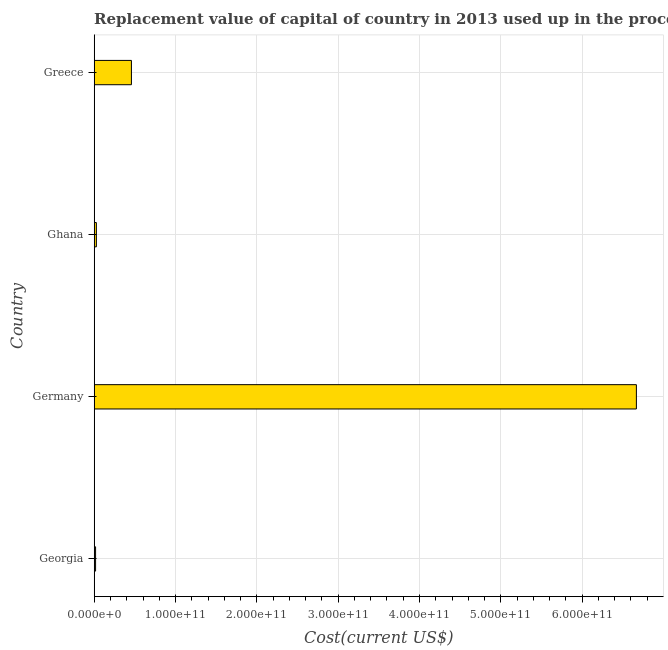Does the graph contain any zero values?
Make the answer very short. No. Does the graph contain grids?
Give a very brief answer. Yes. What is the title of the graph?
Provide a succinct answer. Replacement value of capital of country in 2013 used up in the process of production. What is the label or title of the X-axis?
Give a very brief answer. Cost(current US$). What is the consumption of fixed capital in Greece?
Offer a very short reply. 4.58e+1. Across all countries, what is the maximum consumption of fixed capital?
Provide a short and direct response. 6.67e+11. Across all countries, what is the minimum consumption of fixed capital?
Keep it short and to the point. 1.69e+09. In which country was the consumption of fixed capital minimum?
Keep it short and to the point. Georgia. What is the sum of the consumption of fixed capital?
Offer a terse response. 7.17e+11. What is the difference between the consumption of fixed capital in Germany and Ghana?
Your answer should be compact. 6.64e+11. What is the average consumption of fixed capital per country?
Offer a very short reply. 1.79e+11. What is the median consumption of fixed capital?
Offer a terse response. 2.42e+1. In how many countries, is the consumption of fixed capital greater than 540000000000 US$?
Your answer should be very brief. 1. What is the ratio of the consumption of fixed capital in Georgia to that in Greece?
Your answer should be very brief. 0.04. What is the difference between the highest and the second highest consumption of fixed capital?
Ensure brevity in your answer.  6.21e+11. What is the difference between the highest and the lowest consumption of fixed capital?
Provide a succinct answer. 6.65e+11. How many bars are there?
Provide a succinct answer. 4. Are all the bars in the graph horizontal?
Ensure brevity in your answer.  Yes. What is the difference between two consecutive major ticks on the X-axis?
Keep it short and to the point. 1.00e+11. Are the values on the major ticks of X-axis written in scientific E-notation?
Provide a succinct answer. Yes. What is the Cost(current US$) in Georgia?
Make the answer very short. 1.69e+09. What is the Cost(current US$) of Germany?
Ensure brevity in your answer.  6.67e+11. What is the Cost(current US$) of Ghana?
Your answer should be very brief. 2.68e+09. What is the Cost(current US$) in Greece?
Provide a short and direct response. 4.58e+1. What is the difference between the Cost(current US$) in Georgia and Germany?
Your response must be concise. -6.65e+11. What is the difference between the Cost(current US$) in Georgia and Ghana?
Your answer should be compact. -9.92e+08. What is the difference between the Cost(current US$) in Georgia and Greece?
Provide a succinct answer. -4.41e+1. What is the difference between the Cost(current US$) in Germany and Ghana?
Give a very brief answer. 6.64e+11. What is the difference between the Cost(current US$) in Germany and Greece?
Your answer should be compact. 6.21e+11. What is the difference between the Cost(current US$) in Ghana and Greece?
Offer a very short reply. -4.31e+1. What is the ratio of the Cost(current US$) in Georgia to that in Germany?
Your answer should be compact. 0. What is the ratio of the Cost(current US$) in Georgia to that in Ghana?
Keep it short and to the point. 0.63. What is the ratio of the Cost(current US$) in Georgia to that in Greece?
Give a very brief answer. 0.04. What is the ratio of the Cost(current US$) in Germany to that in Ghana?
Ensure brevity in your answer.  248.48. What is the ratio of the Cost(current US$) in Germany to that in Greece?
Offer a terse response. 14.57. What is the ratio of the Cost(current US$) in Ghana to that in Greece?
Your answer should be compact. 0.06. 